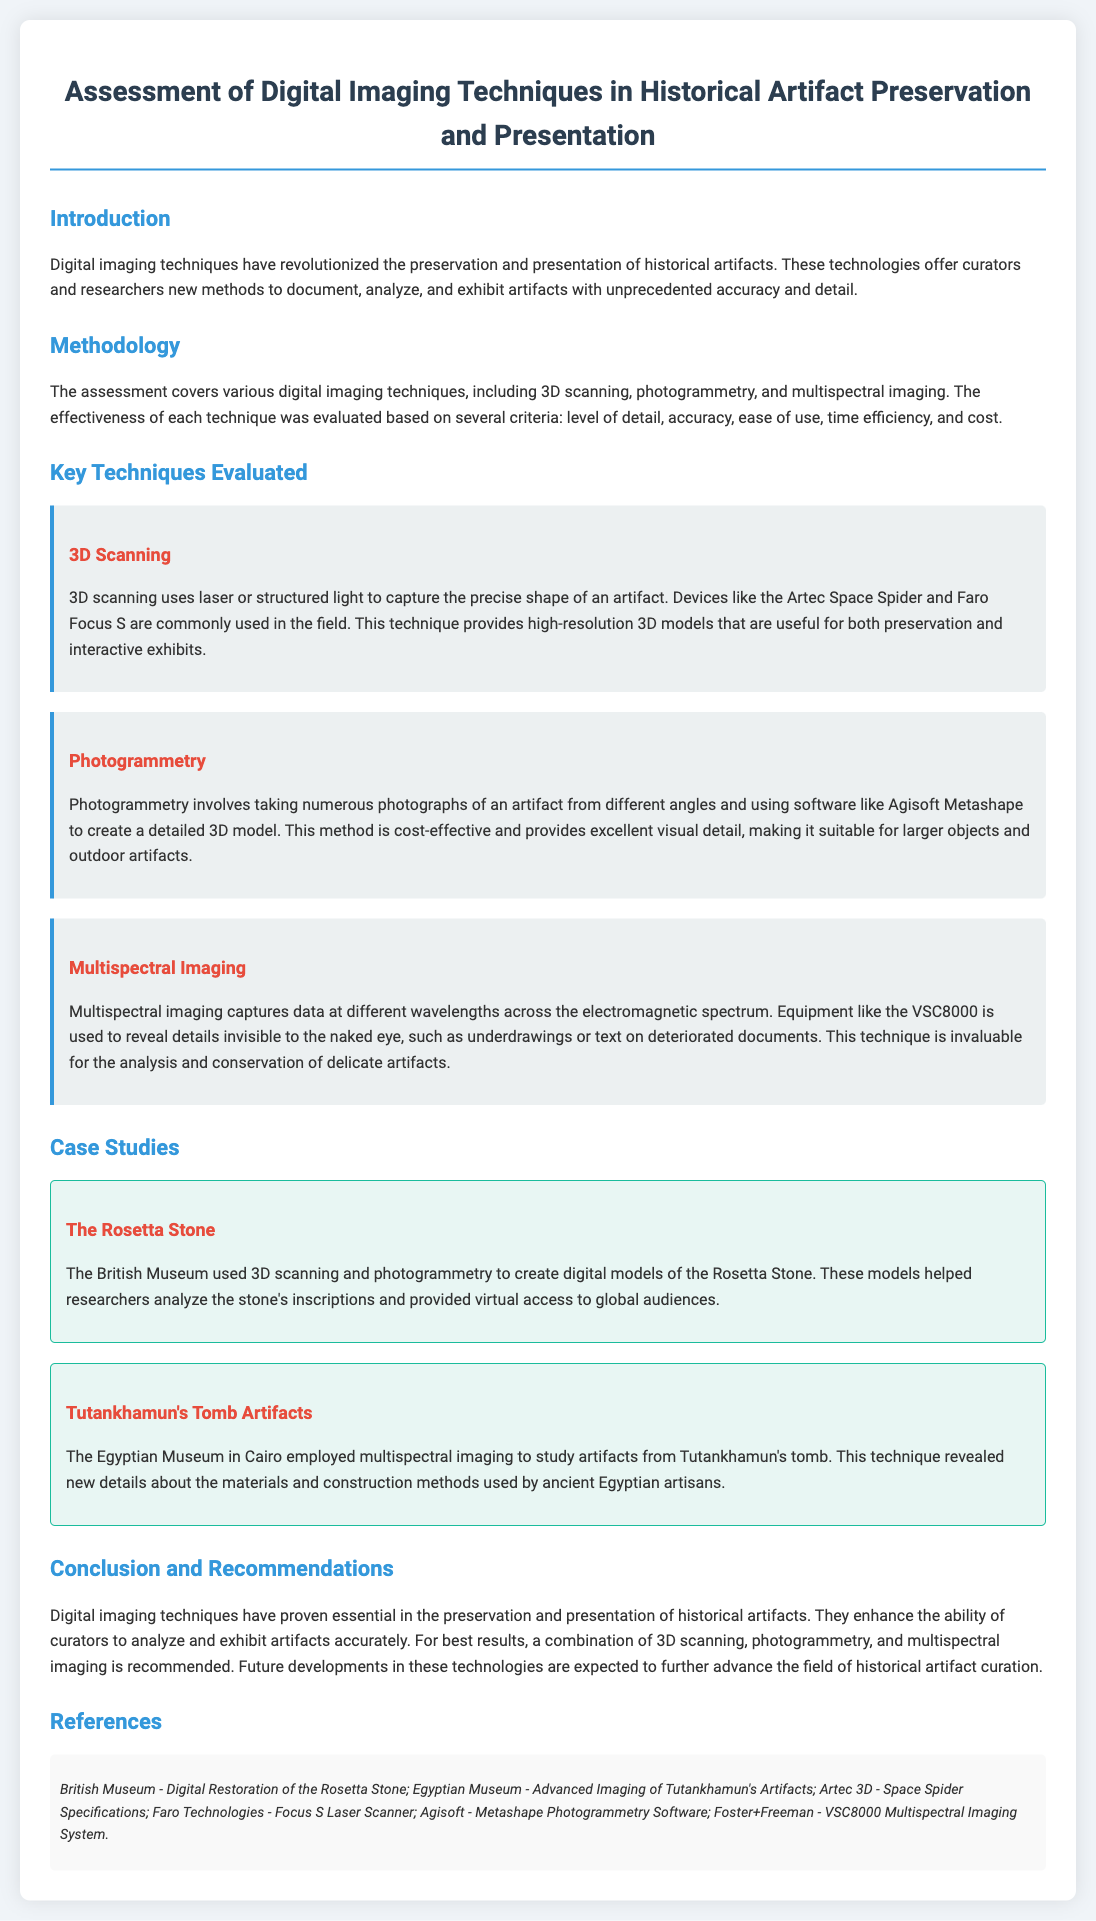What is the title of the document? The title of the document appears as a heading at the top and specifies the main focus of the content.
Answer: Assessment of Digital Imaging Techniques in Historical Artifact Preservation and Presentation What technique uses laser or structured light? This technique is one of the key imaging methods mentioned in the document and is described in detail in a dedicated section.
Answer: 3D Scanning Which software is used for photogrammetry? The document lists specific software associated with the photogrammetry technique for creating 3D models.
Answer: Agisoft Metashape What artifact was studied using multispectral imaging? This information is found in the case studies section, identifying a specific artifact related to ancient Egypt.
Answer: Tutankhamun's Tomb Artifacts Which imaging technique is described as cost-effective? The document classifies and assesses various techniques, indicating this particular technique's affordability.
Answer: Photogrammetry What is the primary benefit of 3D scanning mentioned? Benefits are outlined in the methodologies describing how this technique enhances preservation and presentation efforts.
Answer: High-resolution 3D models How many case studies are referenced? The total number of distinct case studies mentioned provides insight into the practical applications of the techniques evaluated.
Answer: Two Which museum used 3D scanning for the Rosetta Stone? This information is found in the case studies, linking a technique with a specific institution.
Answer: British Museum What is recommended for best results in artifact curation? This recommendation summarizes the preferred approach to employing multiple techniques for optimal outcomes.
Answer: A combination of 3D scanning, photogrammetry, and multispectral imaging 